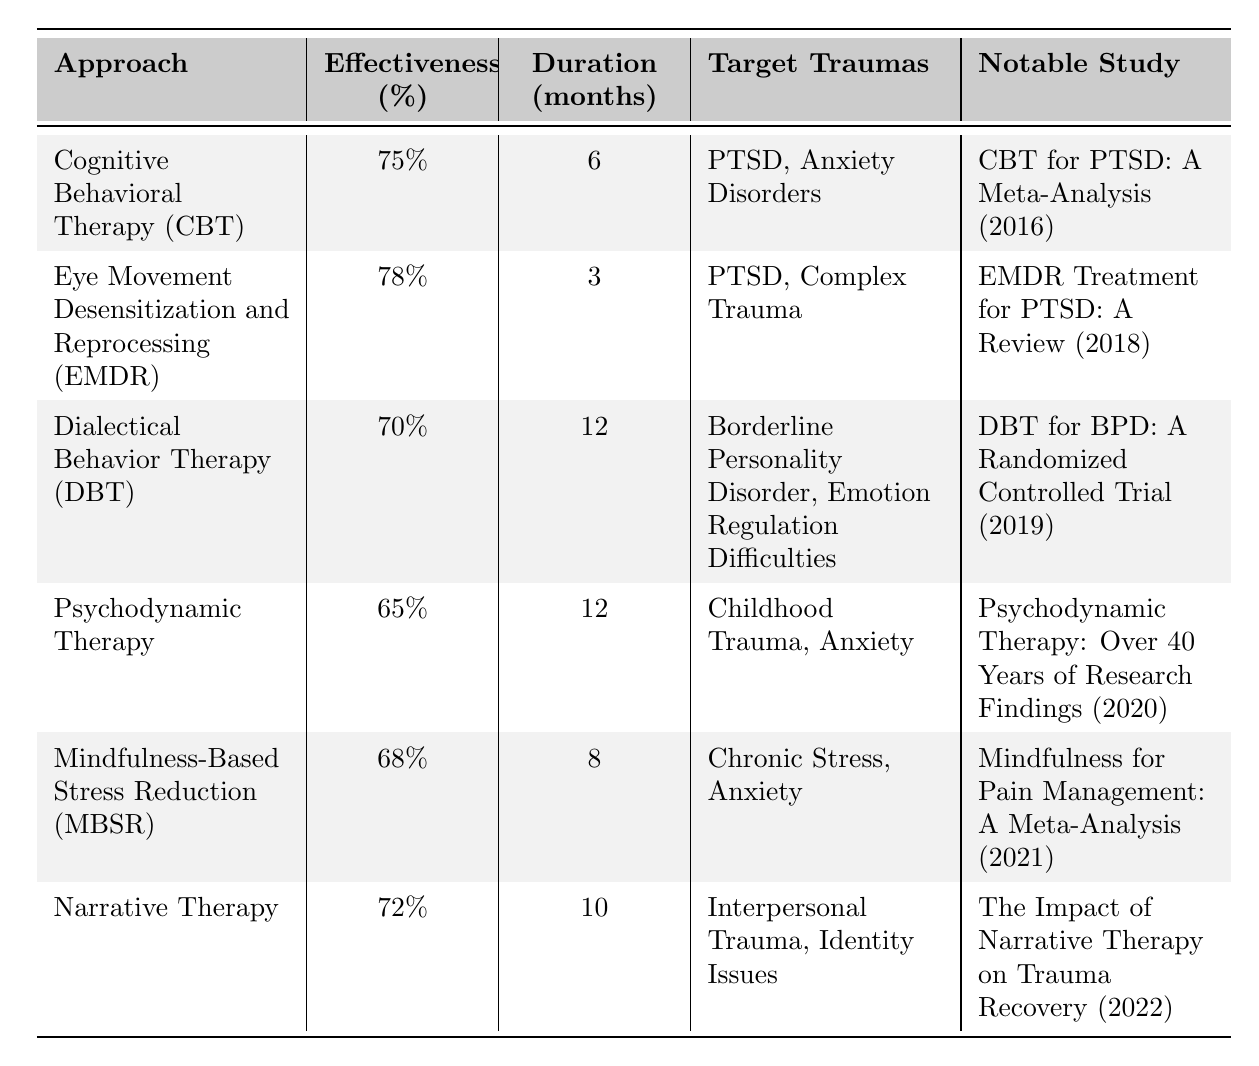What is the effectiveness percentage of Cognitive Behavioral Therapy (CBT)? According to the table, CBT has an effectiveness percentage listed at 75%.
Answer: 75% What is the duration of Eye Movement Desensitization and Reprocessing (EMDR)? The table indicates that EMDR has a duration of 3 months.
Answer: 3 months Which therapeutic approach targets Borderline Personality Disorder? The table specifies that Dialectical Behavior Therapy (DBT) targets Borderline Personality Disorder.
Answer: Dialectical Behavior Therapy (DBT) What is the average effectiveness percentage of the listed therapeutic approaches? To find the average, sum the effectiveness percentages (75 + 78 + 70 + 65 + 68 + 72 = 428) and divide by the number of approaches (6). Therefore, the average is 428 / 6 = 71.33%.
Answer: 71.33% Is Mindfulness-Based Stress Reduction (MBSR) effective for PTSD? The table does not list PTSD as a target trauma for MBSR, indicating it is not specifically effective for it.
Answer: No Which approach has the highest effectiveness percentage? By reviewing the effectiveness percentages, EMDR has the highest percentage at 78%.
Answer: EMDR What is the duration difference between Dialectical Behavior Therapy (DBT) and Psychodynamic Therapy? DBT lasts 12 months and Psychodynamic Therapy also lasts 12 months; therefore, the difference is 12 - 12 = 0 months.
Answer: 0 months Which therapeutic approach has the least effectiveness percentage? The least effectiveness percentage in the table is that of Psychodynamic Therapy at 65%.
Answer: Psychodynamic Therapy How many therapeutic approaches have a duration of less than 6 months? The table shows that EMDR lasts 3 months, which is the only approach under 6 months. Thus, there is 1 approach.
Answer: 1 What therapeutic approach can address both anxiety and chronic stress? Mindfulness-Based Stress Reduction (MBSR) targets anxiety and also addresses chronic stress, according to the table.
Answer: Mindfulness-Based Stress Reduction (MBSR) If you want therapy for PTSD with the quickest duration, which approach should you choose? EMDR has the quickest duration for PTSD treatment at 3 months, making it the best choice.
Answer: EMDR 